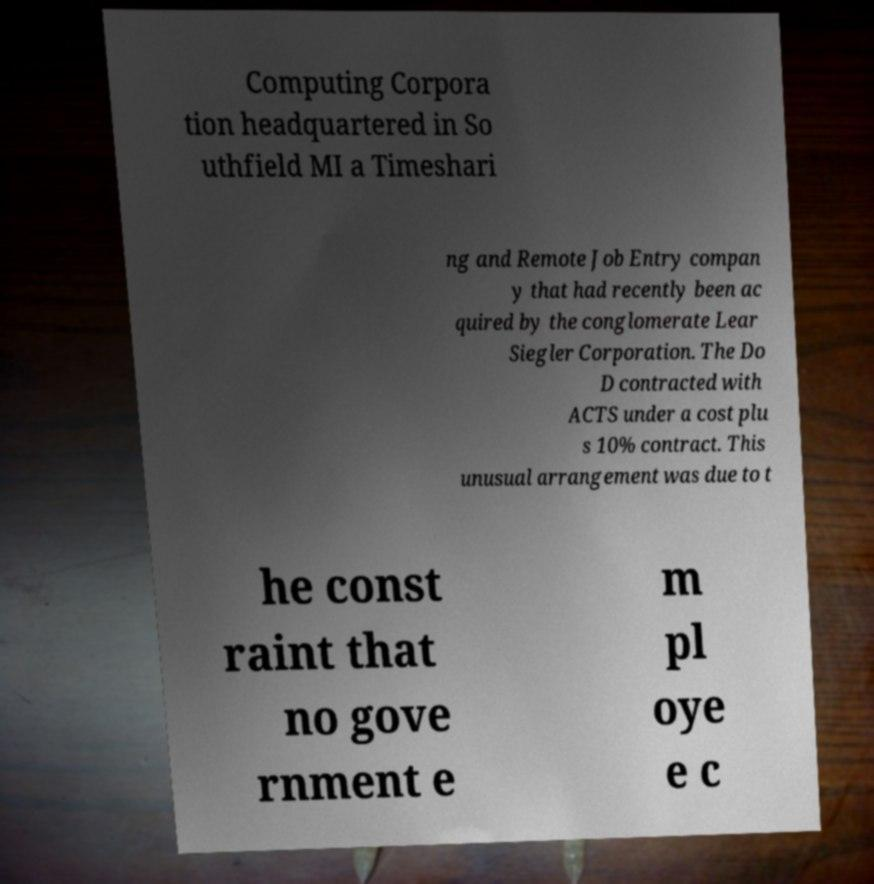For documentation purposes, I need the text within this image transcribed. Could you provide that? Computing Corpora tion headquartered in So uthfield MI a Timeshari ng and Remote Job Entry compan y that had recently been ac quired by the conglomerate Lear Siegler Corporation. The Do D contracted with ACTS under a cost plu s 10% contract. This unusual arrangement was due to t he const raint that no gove rnment e m pl oye e c 